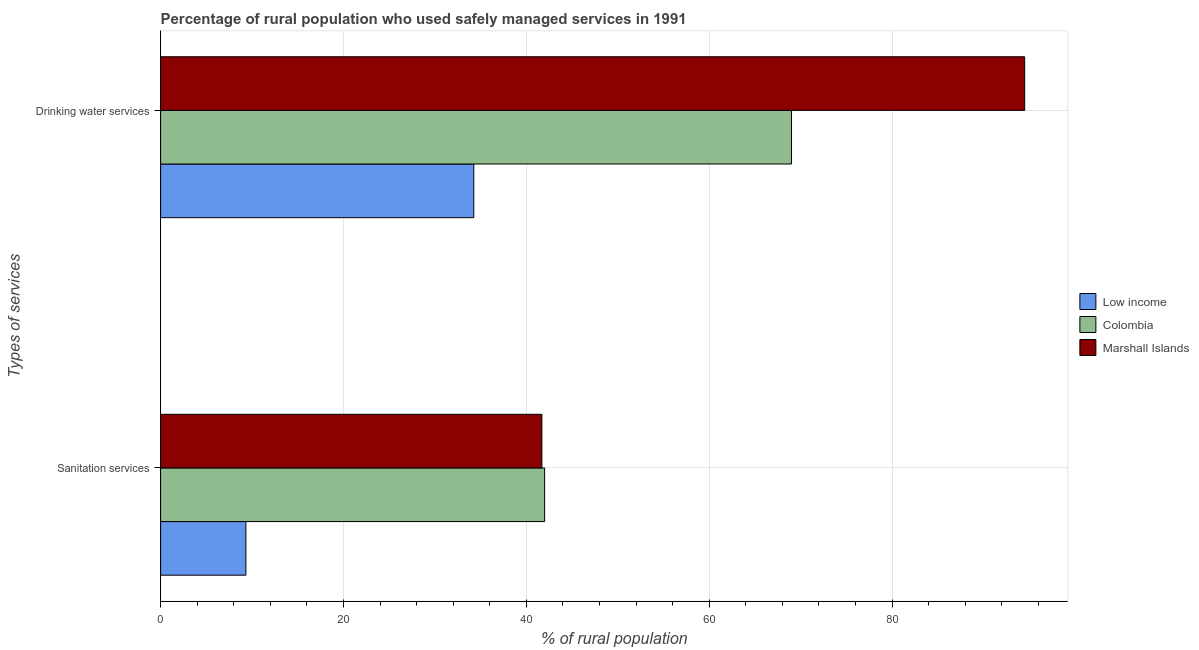Are the number of bars on each tick of the Y-axis equal?
Provide a succinct answer. Yes. What is the label of the 1st group of bars from the top?
Offer a terse response. Drinking water services. What is the percentage of rural population who used sanitation services in Low income?
Ensure brevity in your answer.  9.33. Across all countries, what is the maximum percentage of rural population who used drinking water services?
Your answer should be compact. 94.5. Across all countries, what is the minimum percentage of rural population who used drinking water services?
Offer a very short reply. 34.25. In which country was the percentage of rural population who used drinking water services maximum?
Provide a succinct answer. Marshall Islands. In which country was the percentage of rural population who used sanitation services minimum?
Make the answer very short. Low income. What is the total percentage of rural population who used sanitation services in the graph?
Offer a terse response. 93.03. What is the difference between the percentage of rural population who used sanitation services in Colombia and that in Marshall Islands?
Give a very brief answer. 0.3. What is the difference between the percentage of rural population who used sanitation services in Colombia and the percentage of rural population who used drinking water services in Low income?
Keep it short and to the point. 7.75. What is the average percentage of rural population who used sanitation services per country?
Keep it short and to the point. 31.01. In how many countries, is the percentage of rural population who used drinking water services greater than 48 %?
Ensure brevity in your answer.  2. What is the ratio of the percentage of rural population who used drinking water services in Colombia to that in Marshall Islands?
Give a very brief answer. 0.73. Is the percentage of rural population who used drinking water services in Colombia less than that in Marshall Islands?
Keep it short and to the point. Yes. What does the 3rd bar from the bottom in Drinking water services represents?
Offer a very short reply. Marshall Islands. How many bars are there?
Make the answer very short. 6. How many countries are there in the graph?
Provide a succinct answer. 3. Are the values on the major ticks of X-axis written in scientific E-notation?
Offer a terse response. No. What is the title of the graph?
Provide a succinct answer. Percentage of rural population who used safely managed services in 1991. What is the label or title of the X-axis?
Your response must be concise. % of rural population. What is the label or title of the Y-axis?
Make the answer very short. Types of services. What is the % of rural population in Low income in Sanitation services?
Give a very brief answer. 9.33. What is the % of rural population in Marshall Islands in Sanitation services?
Give a very brief answer. 41.7. What is the % of rural population in Low income in Drinking water services?
Make the answer very short. 34.25. What is the % of rural population in Colombia in Drinking water services?
Give a very brief answer. 69. What is the % of rural population of Marshall Islands in Drinking water services?
Your response must be concise. 94.5. Across all Types of services, what is the maximum % of rural population of Low income?
Your answer should be compact. 34.25. Across all Types of services, what is the maximum % of rural population in Marshall Islands?
Your response must be concise. 94.5. Across all Types of services, what is the minimum % of rural population in Low income?
Your answer should be very brief. 9.33. Across all Types of services, what is the minimum % of rural population of Colombia?
Keep it short and to the point. 42. Across all Types of services, what is the minimum % of rural population in Marshall Islands?
Your response must be concise. 41.7. What is the total % of rural population in Low income in the graph?
Keep it short and to the point. 43.58. What is the total % of rural population in Colombia in the graph?
Provide a succinct answer. 111. What is the total % of rural population of Marshall Islands in the graph?
Your response must be concise. 136.2. What is the difference between the % of rural population in Low income in Sanitation services and that in Drinking water services?
Ensure brevity in your answer.  -24.93. What is the difference between the % of rural population in Colombia in Sanitation services and that in Drinking water services?
Keep it short and to the point. -27. What is the difference between the % of rural population in Marshall Islands in Sanitation services and that in Drinking water services?
Ensure brevity in your answer.  -52.8. What is the difference between the % of rural population in Low income in Sanitation services and the % of rural population in Colombia in Drinking water services?
Provide a short and direct response. -59.67. What is the difference between the % of rural population in Low income in Sanitation services and the % of rural population in Marshall Islands in Drinking water services?
Offer a very short reply. -85.17. What is the difference between the % of rural population in Colombia in Sanitation services and the % of rural population in Marshall Islands in Drinking water services?
Offer a very short reply. -52.5. What is the average % of rural population in Low income per Types of services?
Keep it short and to the point. 21.79. What is the average % of rural population in Colombia per Types of services?
Provide a short and direct response. 55.5. What is the average % of rural population of Marshall Islands per Types of services?
Keep it short and to the point. 68.1. What is the difference between the % of rural population of Low income and % of rural population of Colombia in Sanitation services?
Offer a terse response. -32.67. What is the difference between the % of rural population of Low income and % of rural population of Marshall Islands in Sanitation services?
Your response must be concise. -32.37. What is the difference between the % of rural population of Low income and % of rural population of Colombia in Drinking water services?
Make the answer very short. -34.75. What is the difference between the % of rural population of Low income and % of rural population of Marshall Islands in Drinking water services?
Provide a succinct answer. -60.25. What is the difference between the % of rural population in Colombia and % of rural population in Marshall Islands in Drinking water services?
Keep it short and to the point. -25.5. What is the ratio of the % of rural population in Low income in Sanitation services to that in Drinking water services?
Give a very brief answer. 0.27. What is the ratio of the % of rural population of Colombia in Sanitation services to that in Drinking water services?
Your answer should be compact. 0.61. What is the ratio of the % of rural population of Marshall Islands in Sanitation services to that in Drinking water services?
Your answer should be compact. 0.44. What is the difference between the highest and the second highest % of rural population of Low income?
Offer a terse response. 24.93. What is the difference between the highest and the second highest % of rural population in Colombia?
Your answer should be very brief. 27. What is the difference between the highest and the second highest % of rural population in Marshall Islands?
Provide a short and direct response. 52.8. What is the difference between the highest and the lowest % of rural population in Low income?
Make the answer very short. 24.93. What is the difference between the highest and the lowest % of rural population of Colombia?
Make the answer very short. 27. What is the difference between the highest and the lowest % of rural population in Marshall Islands?
Offer a very short reply. 52.8. 